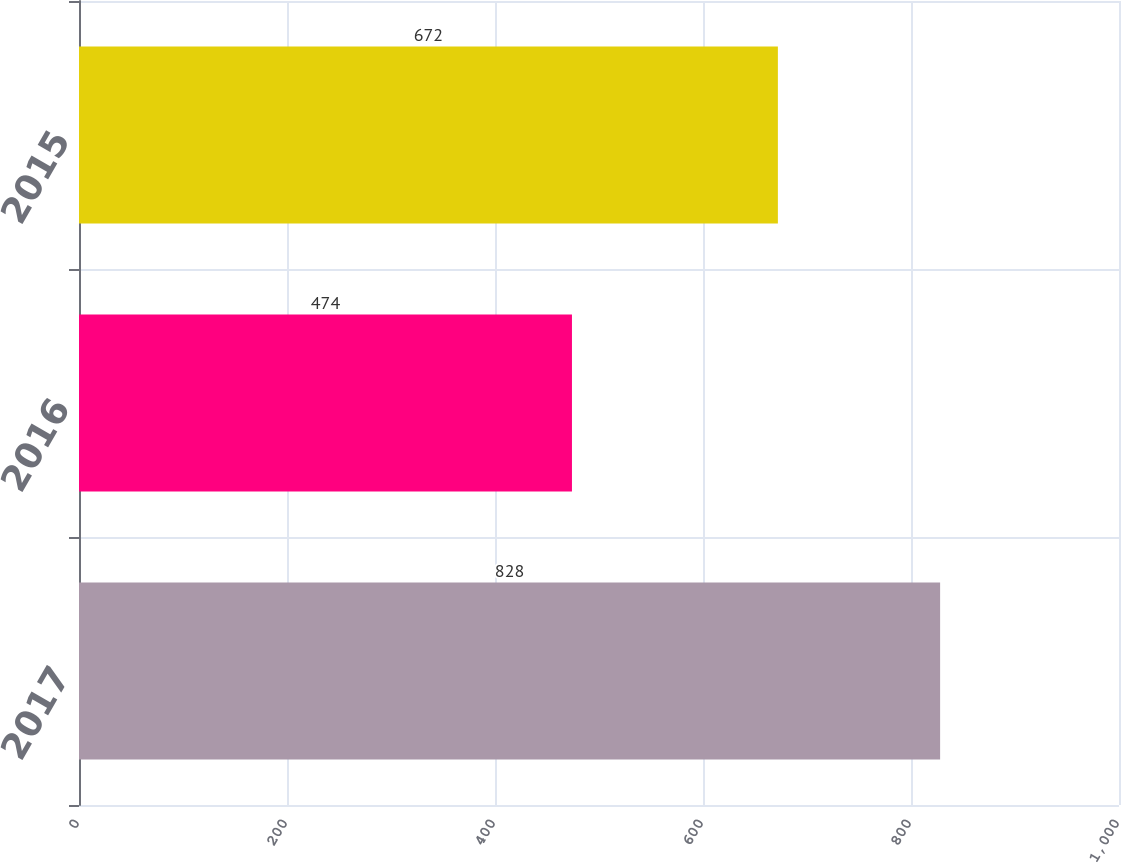<chart> <loc_0><loc_0><loc_500><loc_500><bar_chart><fcel>2017<fcel>2016<fcel>2015<nl><fcel>828<fcel>474<fcel>672<nl></chart> 